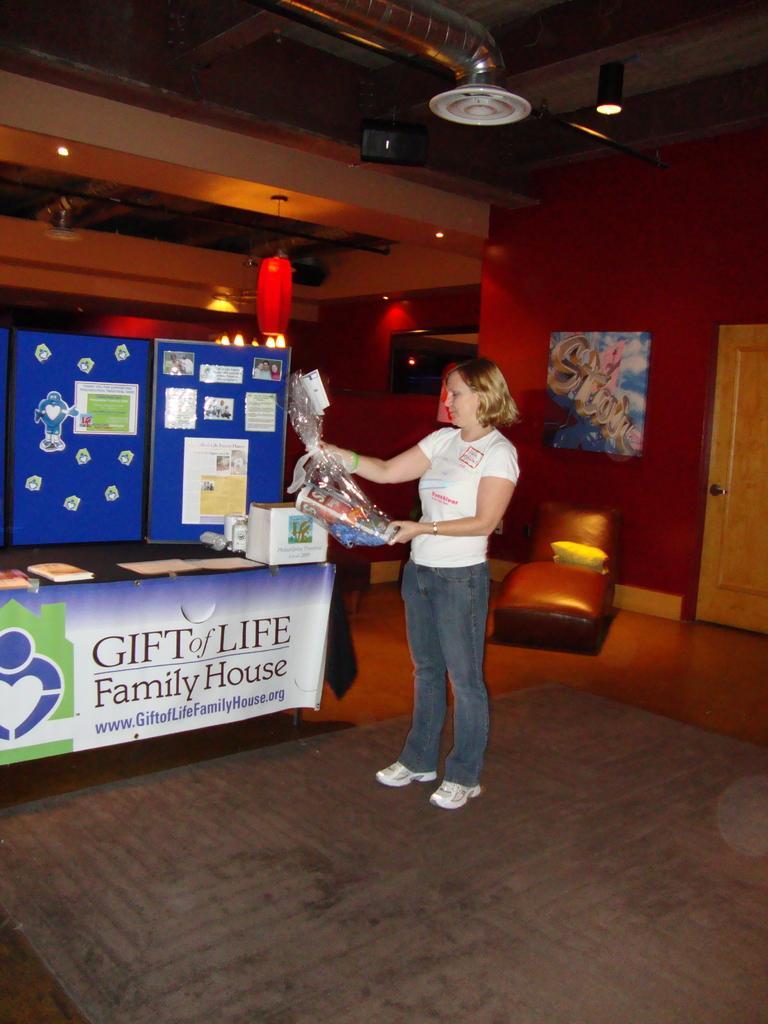Please provide a concise description of this image. Here a woman is standing, she wore a white color t-shirt. In the left side there are machines which are in blue color. At the top it's a light. 